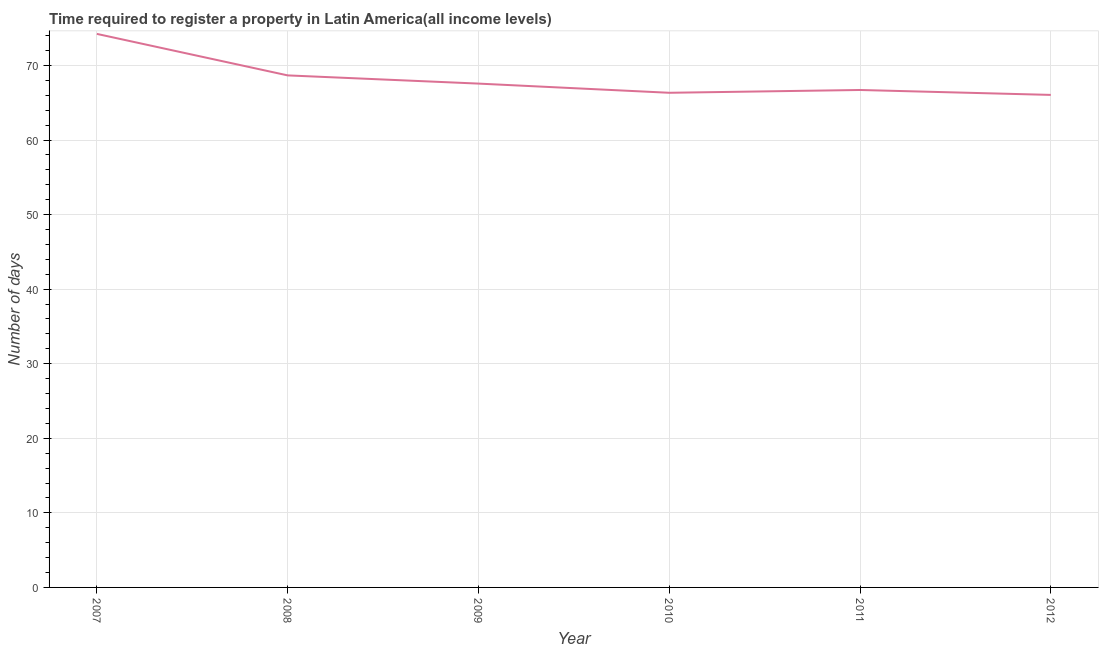What is the number of days required to register property in 2011?
Your answer should be very brief. 66.71. Across all years, what is the maximum number of days required to register property?
Give a very brief answer. 74.23. Across all years, what is the minimum number of days required to register property?
Provide a short and direct response. 66.05. In which year was the number of days required to register property maximum?
Your answer should be compact. 2007. In which year was the number of days required to register property minimum?
Provide a succinct answer. 2012. What is the sum of the number of days required to register property?
Your response must be concise. 409.56. What is the difference between the number of days required to register property in 2007 and 2011?
Give a very brief answer. 7.52. What is the average number of days required to register property per year?
Give a very brief answer. 68.26. What is the median number of days required to register property?
Offer a terse response. 67.14. Do a majority of the years between 2011 and 2012 (inclusive) have number of days required to register property greater than 18 days?
Keep it short and to the point. Yes. What is the ratio of the number of days required to register property in 2011 to that in 2012?
Offer a terse response. 1.01. Is the number of days required to register property in 2008 less than that in 2012?
Keep it short and to the point. No. What is the difference between the highest and the second highest number of days required to register property?
Ensure brevity in your answer.  5.57. Is the sum of the number of days required to register property in 2007 and 2011 greater than the maximum number of days required to register property across all years?
Offer a terse response. Yes. What is the difference between the highest and the lowest number of days required to register property?
Keep it short and to the point. 8.18. What is the difference between two consecutive major ticks on the Y-axis?
Make the answer very short. 10. Does the graph contain any zero values?
Your answer should be very brief. No. Does the graph contain grids?
Offer a very short reply. Yes. What is the title of the graph?
Offer a terse response. Time required to register a property in Latin America(all income levels). What is the label or title of the X-axis?
Your response must be concise. Year. What is the label or title of the Y-axis?
Offer a very short reply. Number of days. What is the Number of days in 2007?
Keep it short and to the point. 74.23. What is the Number of days in 2008?
Your response must be concise. 68.67. What is the Number of days of 2009?
Your answer should be very brief. 67.57. What is the Number of days in 2010?
Your answer should be very brief. 66.33. What is the Number of days in 2011?
Provide a succinct answer. 66.71. What is the Number of days of 2012?
Give a very brief answer. 66.05. What is the difference between the Number of days in 2007 and 2008?
Make the answer very short. 5.57. What is the difference between the Number of days in 2007 and 2009?
Provide a short and direct response. 6.67. What is the difference between the Number of days in 2007 and 2011?
Give a very brief answer. 7.52. What is the difference between the Number of days in 2007 and 2012?
Offer a terse response. 8.18. What is the difference between the Number of days in 2008 and 2009?
Your answer should be very brief. 1.1. What is the difference between the Number of days in 2008 and 2010?
Keep it short and to the point. 2.33. What is the difference between the Number of days in 2008 and 2011?
Provide a succinct answer. 1.96. What is the difference between the Number of days in 2008 and 2012?
Provide a short and direct response. 2.62. What is the difference between the Number of days in 2009 and 2010?
Keep it short and to the point. 1.23. What is the difference between the Number of days in 2009 and 2011?
Your answer should be compact. 0.86. What is the difference between the Number of days in 2009 and 2012?
Your answer should be very brief. 1.52. What is the difference between the Number of days in 2010 and 2011?
Make the answer very short. -0.38. What is the difference between the Number of days in 2010 and 2012?
Give a very brief answer. 0.28. What is the difference between the Number of days in 2011 and 2012?
Offer a terse response. 0.66. What is the ratio of the Number of days in 2007 to that in 2008?
Provide a short and direct response. 1.08. What is the ratio of the Number of days in 2007 to that in 2009?
Provide a short and direct response. 1.1. What is the ratio of the Number of days in 2007 to that in 2010?
Your answer should be compact. 1.12. What is the ratio of the Number of days in 2007 to that in 2011?
Provide a succinct answer. 1.11. What is the ratio of the Number of days in 2007 to that in 2012?
Offer a terse response. 1.12. What is the ratio of the Number of days in 2008 to that in 2010?
Provide a succinct answer. 1.03. What is the ratio of the Number of days in 2008 to that in 2011?
Your answer should be very brief. 1.03. What is the ratio of the Number of days in 2008 to that in 2012?
Keep it short and to the point. 1.04. What is the ratio of the Number of days in 2009 to that in 2010?
Your answer should be very brief. 1.02. What is the ratio of the Number of days in 2009 to that in 2011?
Keep it short and to the point. 1.01. 